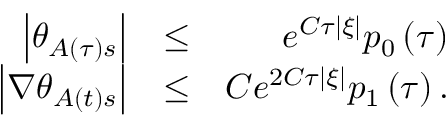Convert formula to latex. <formula><loc_0><loc_0><loc_500><loc_500>\begin{array} { r l r } { \left | \theta _ { A \left ( \tau \right ) s } \right | } & { \leq } & { e ^ { C \tau \left | \xi \right | } p _ { 0 } \left ( \tau \right ) } \\ { \left | \nabla \theta _ { A \left ( t \right ) s } \right | } & { \leq } & { C e ^ { 2 C \tau \left | \xi \right | } p _ { 1 } \left ( \tau \right ) . } \end{array}</formula> 